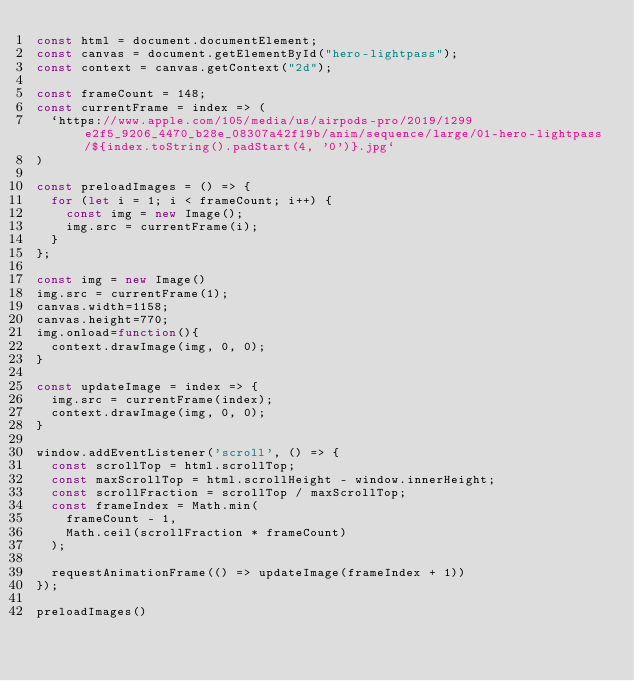Convert code to text. <code><loc_0><loc_0><loc_500><loc_500><_JavaScript_>const html = document.documentElement;
const canvas = document.getElementById("hero-lightpass");
const context = canvas.getContext("2d");

const frameCount = 148;
const currentFrame = index => (
  `https://www.apple.com/105/media/us/airpods-pro/2019/1299e2f5_9206_4470_b28e_08307a42f19b/anim/sequence/large/01-hero-lightpass/${index.toString().padStart(4, '0')}.jpg`
)

const preloadImages = () => {
  for (let i = 1; i < frameCount; i++) {
    const img = new Image();
    img.src = currentFrame(i);
  }
};

const img = new Image()
img.src = currentFrame(1);
canvas.width=1158;
canvas.height=770;
img.onload=function(){
  context.drawImage(img, 0, 0);
}

const updateImage = index => {
  img.src = currentFrame(index);
  context.drawImage(img, 0, 0);
}

window.addEventListener('scroll', () => {  
  const scrollTop = html.scrollTop;
  const maxScrollTop = html.scrollHeight - window.innerHeight;
  const scrollFraction = scrollTop / maxScrollTop;
  const frameIndex = Math.min(
    frameCount - 1,
    Math.ceil(scrollFraction * frameCount)
  );
  
  requestAnimationFrame(() => updateImage(frameIndex + 1))
});

preloadImages()</code> 